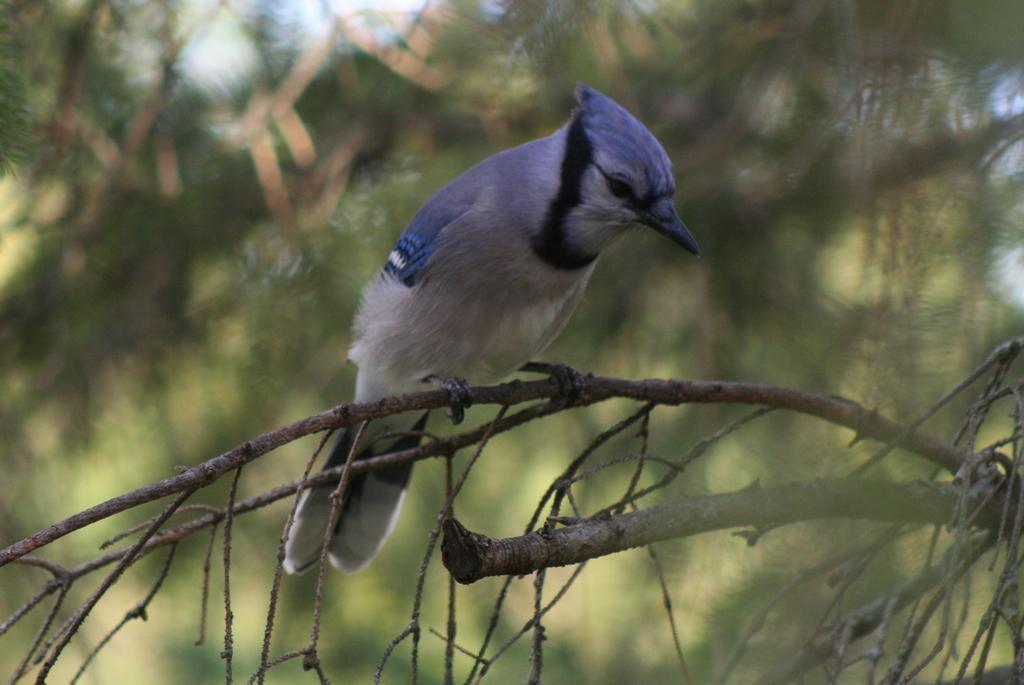In one or two sentences, can you explain what this image depicts? In the foreground of the picture we can see a bird sitting on the stem. The background is blurred. 